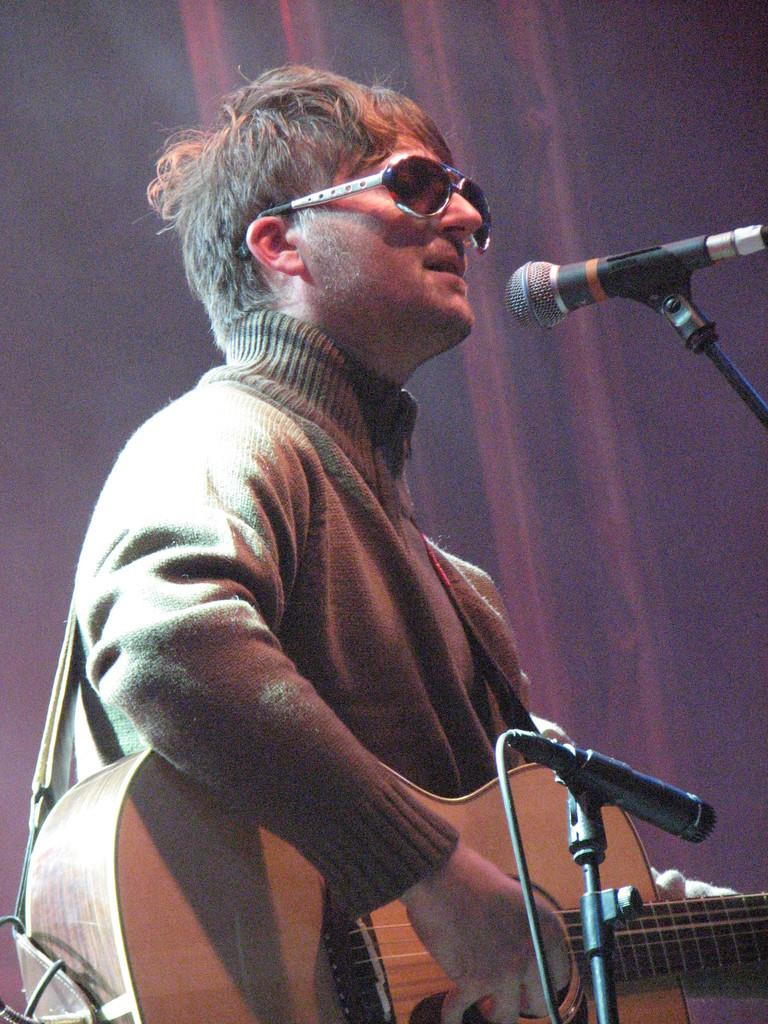What is the main feature of the image? There is a stage in the image. What can be seen on the stage? There are two microphones on the stage. What is the person on the stage doing? A person is playing the guitar in front of the microphones. Can you describe the appearance of the person on the stage? The person is wearing black-rimmed spectacles and a chocolate-colored woolen coat. What type of grape is the person on the stage eating? There is no grape present in the image, and the person is not eating anything. How does the person's behavior affect the audience's nerves? The image does not provide information about the audience's nerves or the person's behavior affecting them. 